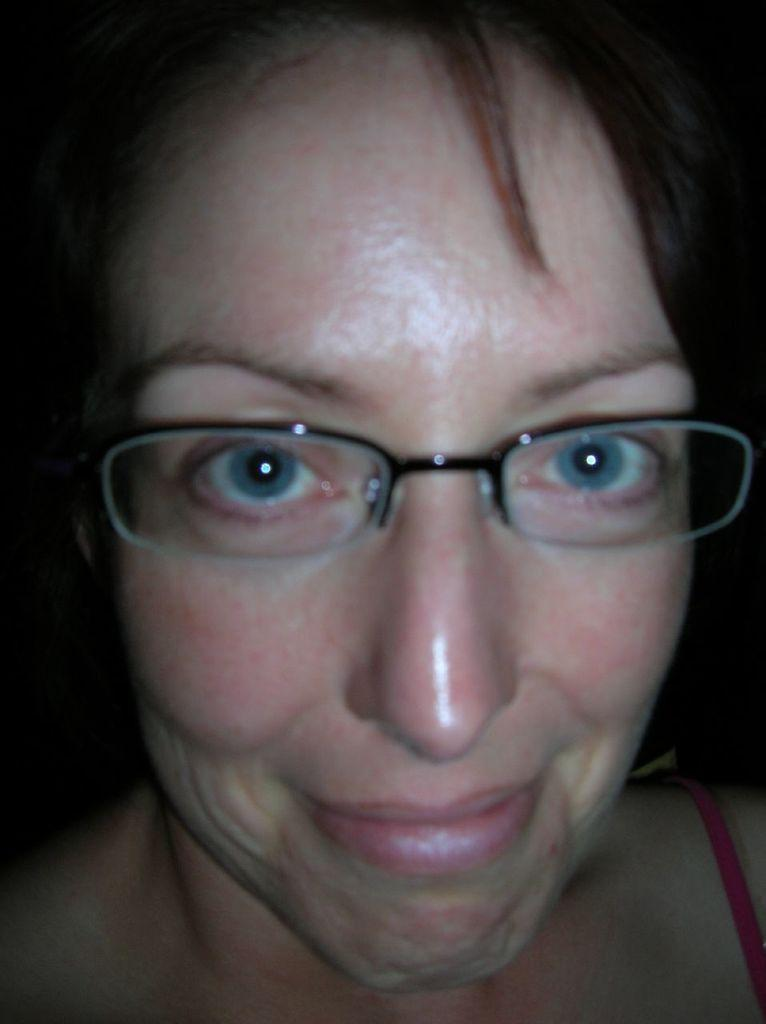What is the main subject of the image? There is a person in the image. What can be observed about the background of the image? The background of the image is dark. What type of bottle is the person holding in the image? There is no bottle present in the image. How does the person's behavior change when faced with fear in the image? There is no indication of fear or any behavioral changes in the image. 